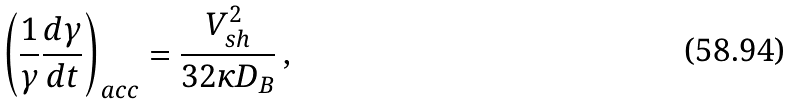Convert formula to latex. <formula><loc_0><loc_0><loc_500><loc_500>\left ( \frac { 1 } { \gamma } \frac { d \gamma } { d t } \right ) _ { a c c } = \frac { V _ { s h } ^ { 2 } } { 3 2 \kappa D _ { B } } \, ,</formula> 